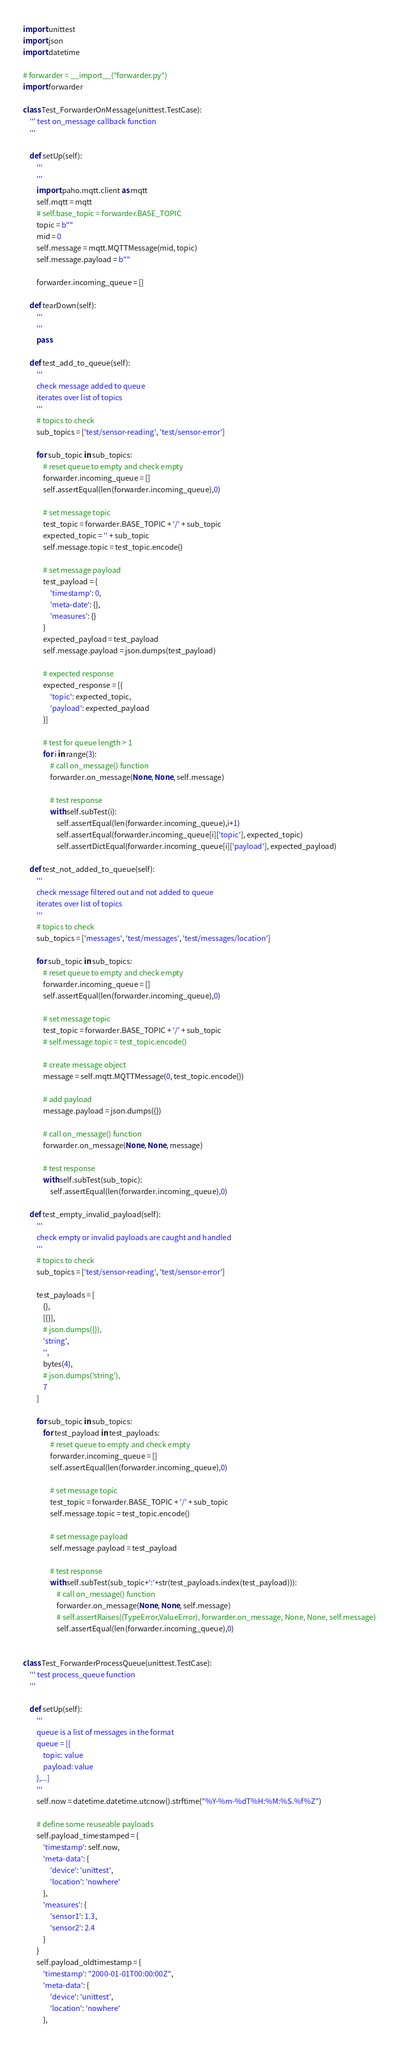<code> <loc_0><loc_0><loc_500><loc_500><_Python_>import unittest
import json
import datetime

# forwarder = __import__("forwarder.py")
import forwarder

class Test_ForwarderOnMessage(unittest.TestCase):
    ''' test on_message callback function
    '''
    
    def setUp(self):
        '''
        '''
        import paho.mqtt.client as mqtt
        self.mqtt = mqtt
        # self.base_topic = forwarder.BASE_TOPIC
        topic = b""
        mid = 0
        self.message = mqtt.MQTTMessage(mid, topic)
        self.message.payload = b""

        forwarder.incoming_queue = []

    def tearDown(self):
        '''
        '''
        pass

    def test_add_to_queue(self):
        '''
        check message added to queue
        iterates over list of topics
        '''
        # topics to check
        sub_topics = ['test/sensor-reading', 'test/sensor-error']

        for sub_topic in sub_topics:
            # reset queue to empty and check empty
            forwarder.incoming_queue = []
            self.assertEqual(len(forwarder.incoming_queue),0)

            # set message topic
            test_topic = forwarder.BASE_TOPIC + '/' + sub_topic
            expected_topic = '' + sub_topic
            self.message.topic = test_topic.encode()

            # set message payload
            test_payload = {
                'timestamp': 0,
                'meta-date': {},
                'measures': {}
            }
            expected_payload = test_payload
            self.message.payload = json.dumps(test_payload)

            # expected response
            expected_response = [{
                'topic': expected_topic,
                'payload': expected_payload
            }]

            # test for queue length > 1
            for i in range(3):
                # call on_message() function
                forwarder.on_message(None, None, self.message)

                # test response
                with self.subTest(i):
                    self.assertEqual(len(forwarder.incoming_queue),i+1)
                    self.assertEqual(forwarder.incoming_queue[i]['topic'], expected_topic)
                    self.assertDictEqual(forwarder.incoming_queue[i]['payload'], expected_payload)

    def test_not_added_to_queue(self):
        '''
        check message filtered out and not added to queue
        iterates over list of topics
        '''
        # topics to check
        sub_topics = ['messages', 'test/messages', 'test/messages/location']

        for sub_topic in sub_topics:
            # reset queue to empty and check empty
            forwarder.incoming_queue = []
            self.assertEqual(len(forwarder.incoming_queue),0)

            # set message topic
            test_topic = forwarder.BASE_TOPIC + '/' + sub_topic
            # self.message.topic = test_topic.encode()

            # create message object
            message = self.mqtt.MQTTMessage(0, test_topic.encode())

            # add payload
            message.payload = json.dumps({})

            # call on_message() function
            forwarder.on_message(None, None, message)

            # test response
            with self.subTest(sub_topic):
                self.assertEqual(len(forwarder.incoming_queue),0)

    def test_empty_invalid_payload(self):
        '''
        check empty or invalid payloads are caught and handled
        '''
        # topics to check
        sub_topics = ['test/sensor-reading', 'test/sensor-error']

        test_payloads = [
            {},
            [{}],
            # json.dumps({}),
            'string',
            '',
            bytes(4),
            # json.dumps('string'),
            7
        ]

        for sub_topic in sub_topics:
            for test_payload in test_payloads:
                # reset queue to empty and check empty
                forwarder.incoming_queue = []
                self.assertEqual(len(forwarder.incoming_queue),0)

                # set message topic
                test_topic = forwarder.BASE_TOPIC + '/' + sub_topic
                self.message.topic = test_topic.encode()

                # set message payload
                self.message.payload = test_payload

                # test response
                with self.subTest(sub_topic+':'+str(test_payloads.index(test_payload))):
                    # call on_message() function
                    forwarder.on_message(None, None, self.message)
                    # self.assertRaises((TypeError,ValueError), forwarder.on_message, None, None, self.message)
                    self.assertEqual(len(forwarder.incoming_queue),0)


class Test_ForwarderProcessQueue(unittest.TestCase):
    ''' test process_queue function
    '''

    def setUp(self):
        '''
        queue is a list of messages in the format
        queue = [{
            topic: value
            payload: value
        },...]
        '''
        self.now = datetime.datetime.utcnow().strftime("%Y-%m-%dT%H:%M:%S.%f%Z")

        # define some reuseable payloads
        self.payload_timestamped = {
            'timestamp': self.now,
            'meta-data': {
                'device': 'unittest',
                'location': 'nowhere'
            },
            'measures': {
                'sensor1': 1.3,
                'sensor2': 2.4
            }
        }
        self.payload_oldtimestamp = {
            'timestamp': "2000-01-01T00:00:00Z",
            'meta-data': {
                'device': 'unittest',
                'location': 'nowhere'
            },</code> 